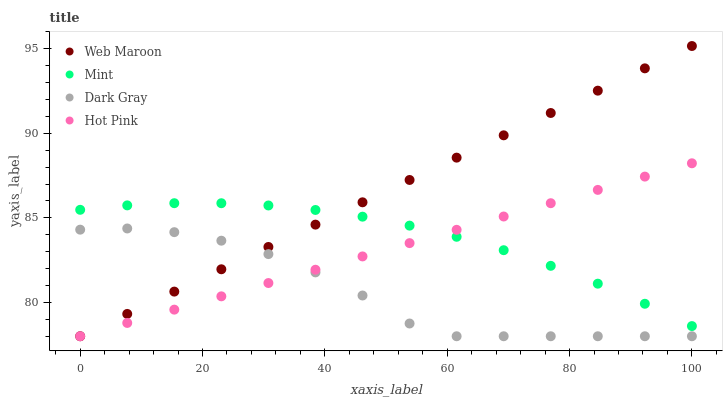Does Dark Gray have the minimum area under the curve?
Answer yes or no. Yes. Does Web Maroon have the maximum area under the curve?
Answer yes or no. Yes. Does Mint have the minimum area under the curve?
Answer yes or no. No. Does Mint have the maximum area under the curve?
Answer yes or no. No. Is Web Maroon the smoothest?
Answer yes or no. Yes. Is Dark Gray the roughest?
Answer yes or no. Yes. Is Mint the smoothest?
Answer yes or no. No. Is Mint the roughest?
Answer yes or no. No. Does Dark Gray have the lowest value?
Answer yes or no. Yes. Does Mint have the lowest value?
Answer yes or no. No. Does Web Maroon have the highest value?
Answer yes or no. Yes. Does Mint have the highest value?
Answer yes or no. No. Is Dark Gray less than Mint?
Answer yes or no. Yes. Is Mint greater than Dark Gray?
Answer yes or no. Yes. Does Web Maroon intersect Mint?
Answer yes or no. Yes. Is Web Maroon less than Mint?
Answer yes or no. No. Is Web Maroon greater than Mint?
Answer yes or no. No. Does Dark Gray intersect Mint?
Answer yes or no. No. 